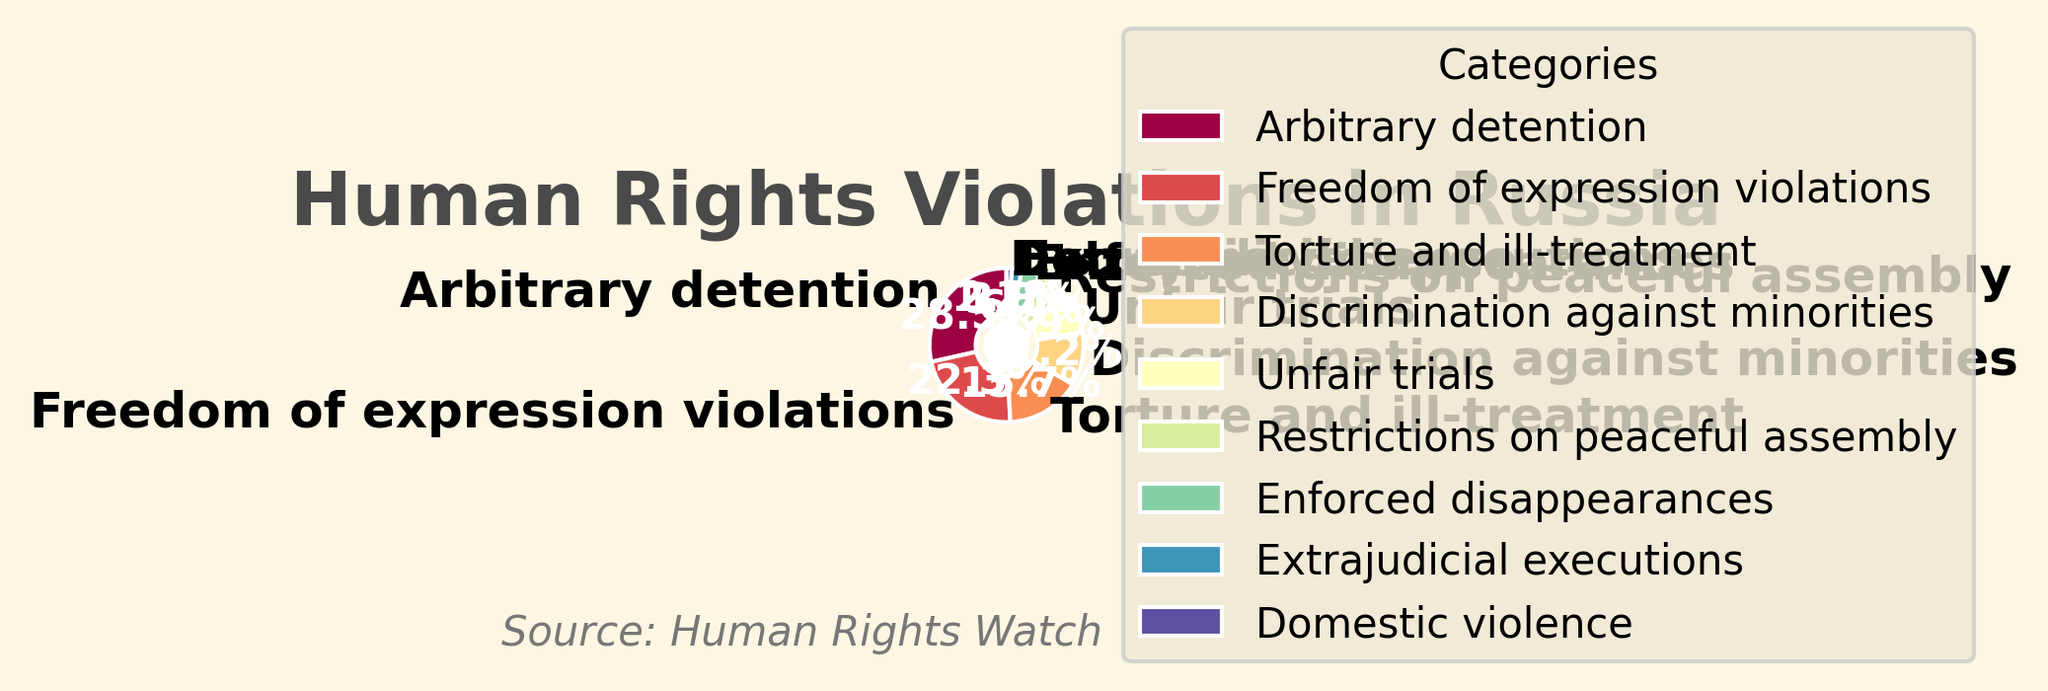Which category has the highest percentage of violations? Look at the pie chart and identify the segment with the largest proportion. 'Arbitrary detention' has the largest slice at 28.5%.
Answer: Arbitrary detention Which category has the lowest percentage of violations? Look at the pie chart for the smallest segment. 'Domestic violence' has the smallest slice at 1.1%.
Answer: Domestic violence How much more percentage does 'Arbitrary detention' have compared to 'Freedom of expression violations'? Subtract the percentage of 'Freedom of expression violations' (22.3%) from 'Arbitrary detention' (28.5%). 28.5% - 22.3% = 6.2%.
Answer: 6.2% What is the combined percentage for 'Torture and ill-treatment' and 'Discrimination against minorities'? Add the percentages of the two categories: 15.7% + 11.2% = 26.9%.
Answer: 26.9% Which categories have percentages greater than 10%? Identify the categories with percentages higher than 10%: 'Arbitrary detention' (28.5%), 'Freedom of expression violations' (22.3%), and 'Torture and ill-treatment' (15.7%), 'Discrimination against minorities' (11.2%).
Answer: Arbitrary detention, Freedom of expression violations, Torture and ill-treatment, Discrimination against minorities Which category has a green color in the pie chart? Find the segment with the green color. Based on the spectral color mapping, 'Unfair trials' is likely to have a green shade.
Answer: Unfair trials How do 'Restrictions on peaceful assembly' and 'Enforced disappearances' compare in terms of percentage? Compare the slices. 'Restrictions on peaceful assembly' is 6.4%, which is larger than 'Enforced disappearances' at 3.8%.
Answer: Restrictions on peaceful assembly has a higher percentage What is the cumulative percentage of the categories with a percentage less than 5%? Add the percentages of 'Enforced disappearances' (3.8%), 'Extrajudicial executions' (2.1%), and 'Domestic violence' (1.1%): 3.8% + 2.1% + 1.1% = 7.0%.
Answer: 7.0% What visual element indicates the source of the data? Identify annotations in the chart. The source is mentioned as 'Source: Human Rights Watch' near the bottom right, annotated in italic.
Answer: Annotation at the bottom right How do 'Extrajudicial executions' and 'Enforced disappearances' compare visually on the pie chart? Look at their slices' relative sizes and colors. 'Enforced disappearances' has a larger slice (3.8%) compared to 'Extrajudicial executions' (2.1%). Both likely follow a similar spectral color progression pattern.
Answer: Enforced disappearances has a larger slice 